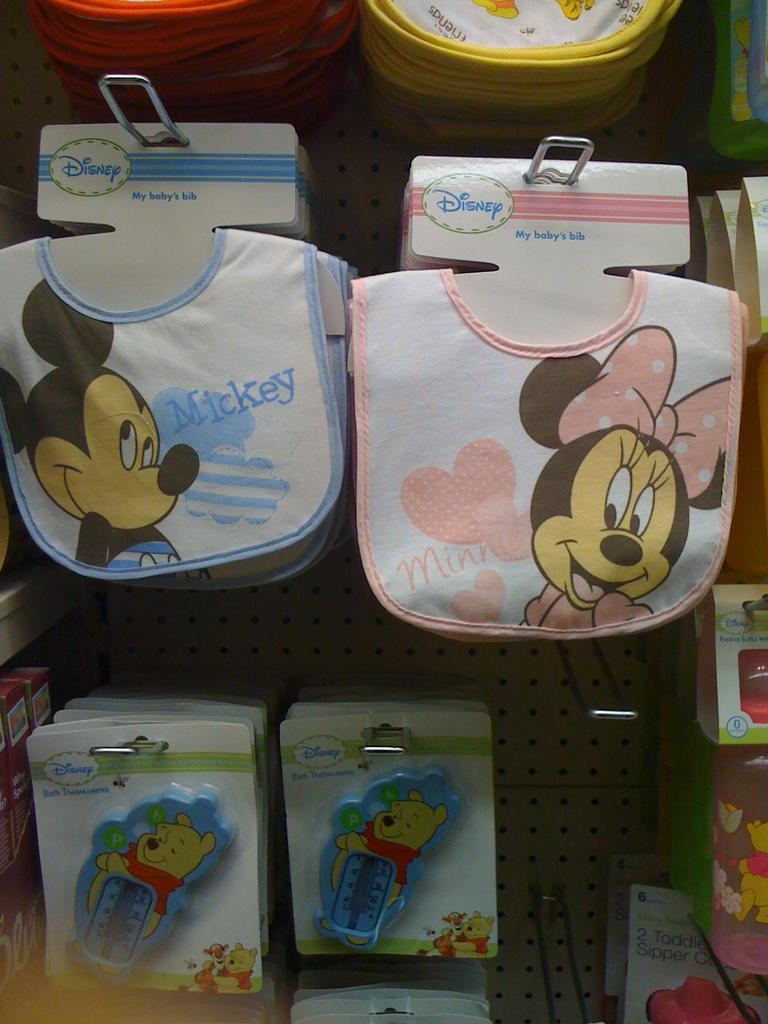What type of napkins are visible in the image? There are baby napkins in the image. What can be seen on the board in the image? There are toys on a board in the image. Where is the mom in the image? There is no mom present in the image. What type of grain is visible in the image? There is no grain present in the image. 